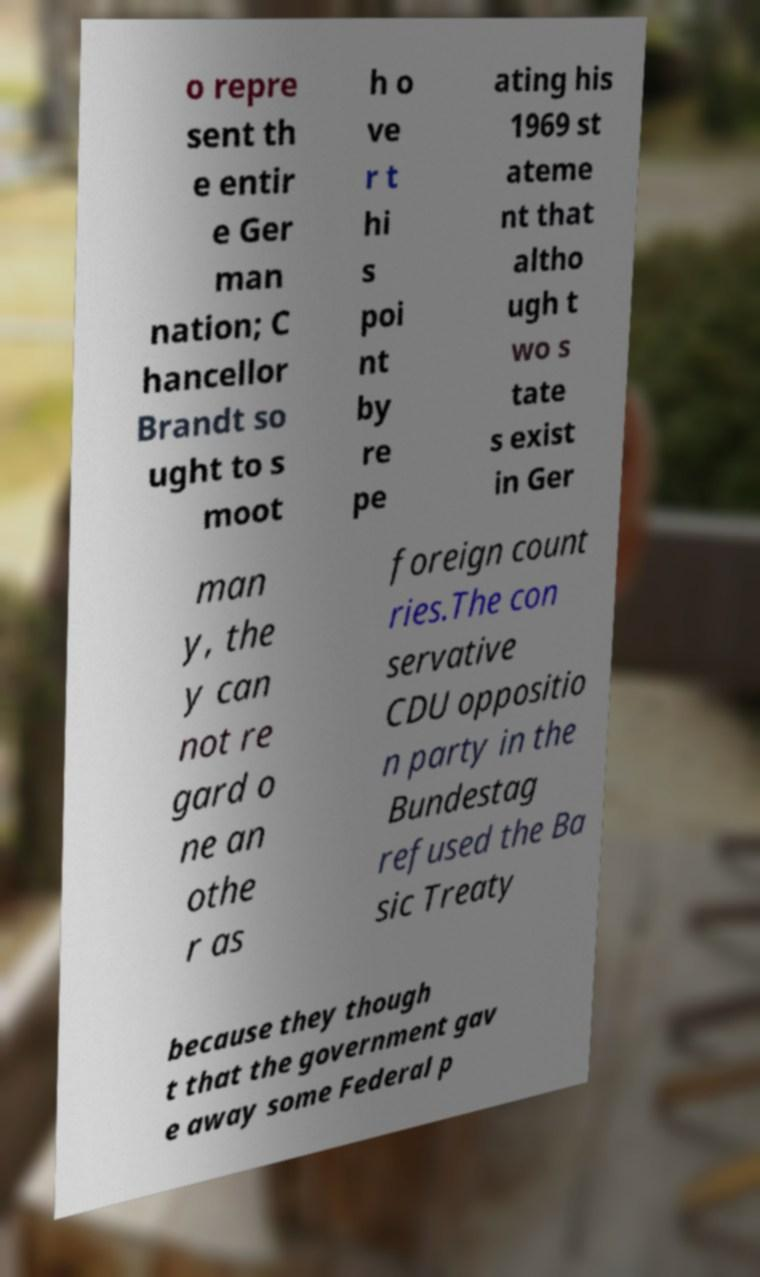Please identify and transcribe the text found in this image. o repre sent th e entir e Ger man nation; C hancellor Brandt so ught to s moot h o ve r t hi s poi nt by re pe ating his 1969 st ateme nt that altho ugh t wo s tate s exist in Ger man y, the y can not re gard o ne an othe r as foreign count ries.The con servative CDU oppositio n party in the Bundestag refused the Ba sic Treaty because they though t that the government gav e away some Federal p 